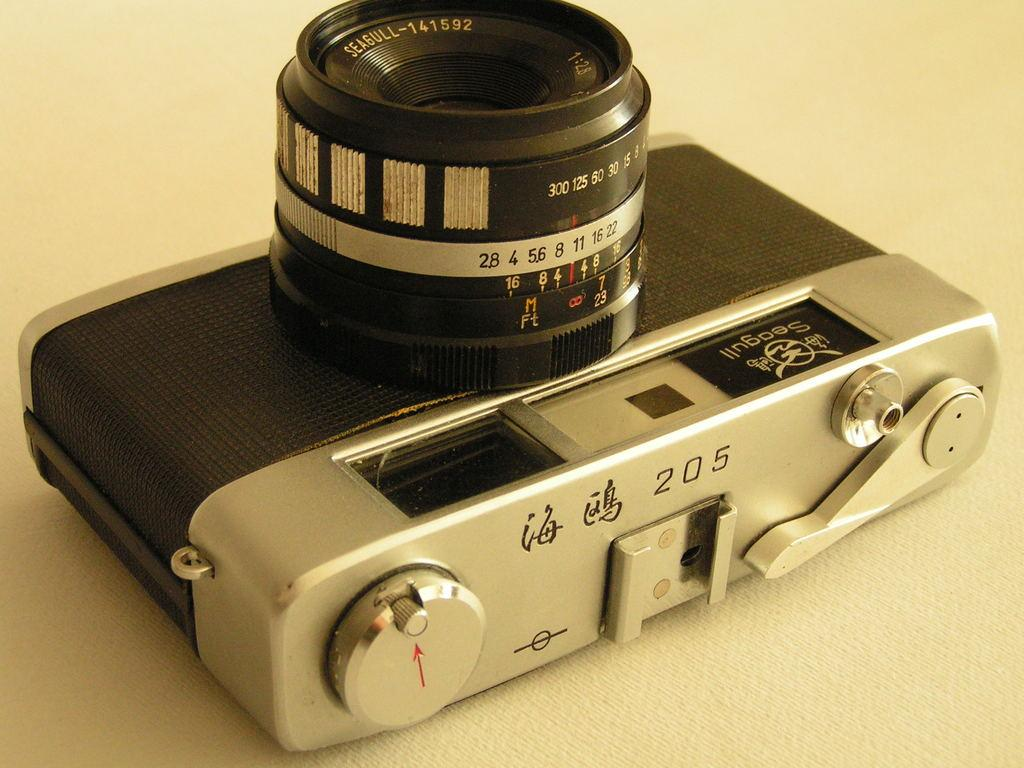What object is the main focus of the image? There is a camera in the image. How many apples are placed on the camera in the image? There are no apples present in the image; it only features a camera. What type of plant is growing out of the camera in the image? There is no plant growing out of the camera in the image; it only features a camera. 